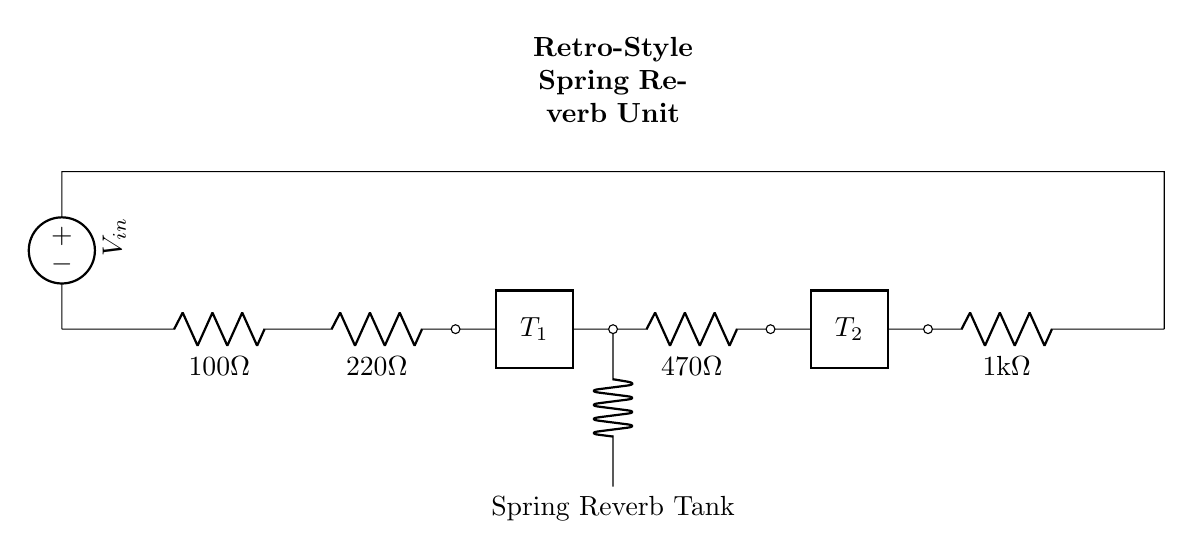What is the value of resistor R1? The value of resistor R1 is given as 100 ohms in the circuit diagram.
Answer: 100 ohms What type of circuit is depicted in this diagram? The diagram illustrates a series circuit configuration, where components are connected end-to-end, allowing a single path for current flow.
Answer: Series circuit How many resistors are present in the circuit? There are a total of four resistors labeled R1, R2, R3, and R4 in the diagram, each connected in series.
Answer: Four What component represents the spring reverb tank in the circuit? The component labeled "Spring Reverb Tank" in the circuit denotes the specific element used for creating reverb effects by utilizing a spring mechanism.
Answer: Spring Reverb Tank What is the value of the last resistor, R4? The value of resistor R4 is indicated as 1 kilohm in the circuit diagram, which is equivalent to 1000 ohms.
Answer: 1 kilohm If the input voltage is 10 volts, what is the voltage across R2? To calculate the voltage across R2, we first need to determine the total resistance in the circuit (100 + 220 + 470 + 1000 ohms). The current can then be found using Ohm's law and the voltage across R2 will be determined by the current flowing through it multiplied by R2's resistance. This would require multiple steps, including calculating the total resistance and current.
Answer: 1.82 volts (approx) 